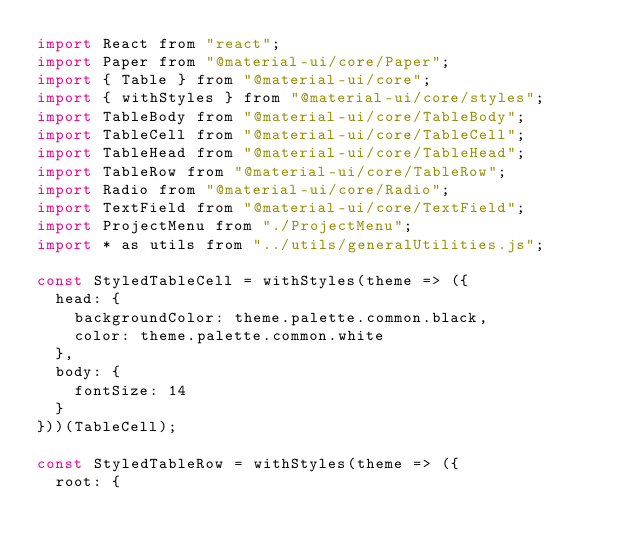Convert code to text. <code><loc_0><loc_0><loc_500><loc_500><_JavaScript_>import React from "react";
import Paper from "@material-ui/core/Paper";
import { Table } from "@material-ui/core";
import { withStyles } from "@material-ui/core/styles";
import TableBody from "@material-ui/core/TableBody";
import TableCell from "@material-ui/core/TableCell";
import TableHead from "@material-ui/core/TableHead";
import TableRow from "@material-ui/core/TableRow";
import Radio from "@material-ui/core/Radio";
import TextField from "@material-ui/core/TextField";
import ProjectMenu from "./ProjectMenu";
import * as utils from "../utils/generalUtilities.js";

const StyledTableCell = withStyles(theme => ({
  head: {
    backgroundColor: theme.palette.common.black,
    color: theme.palette.common.white
  },
  body: {
    fontSize: 14
  }
}))(TableCell);

const StyledTableRow = withStyles(theme => ({
  root: {</code> 